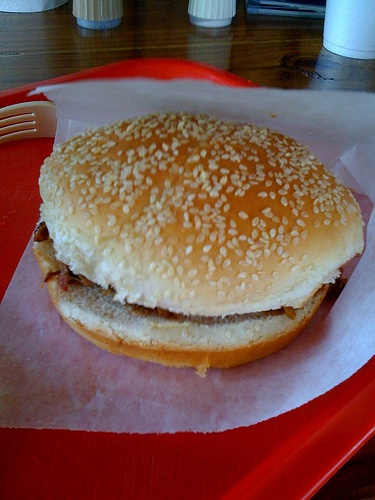Describe the objects in this image and their specific colors. I can see dining table in lightblue, maroon, gray, darkgray, and tan tones, sandwich in lightblue, darkgray, tan, brown, and gray tones, dining table in lightblue, black, purple, and blue tones, and fork in lightblue, maroon, gray, and darkgray tones in this image. 